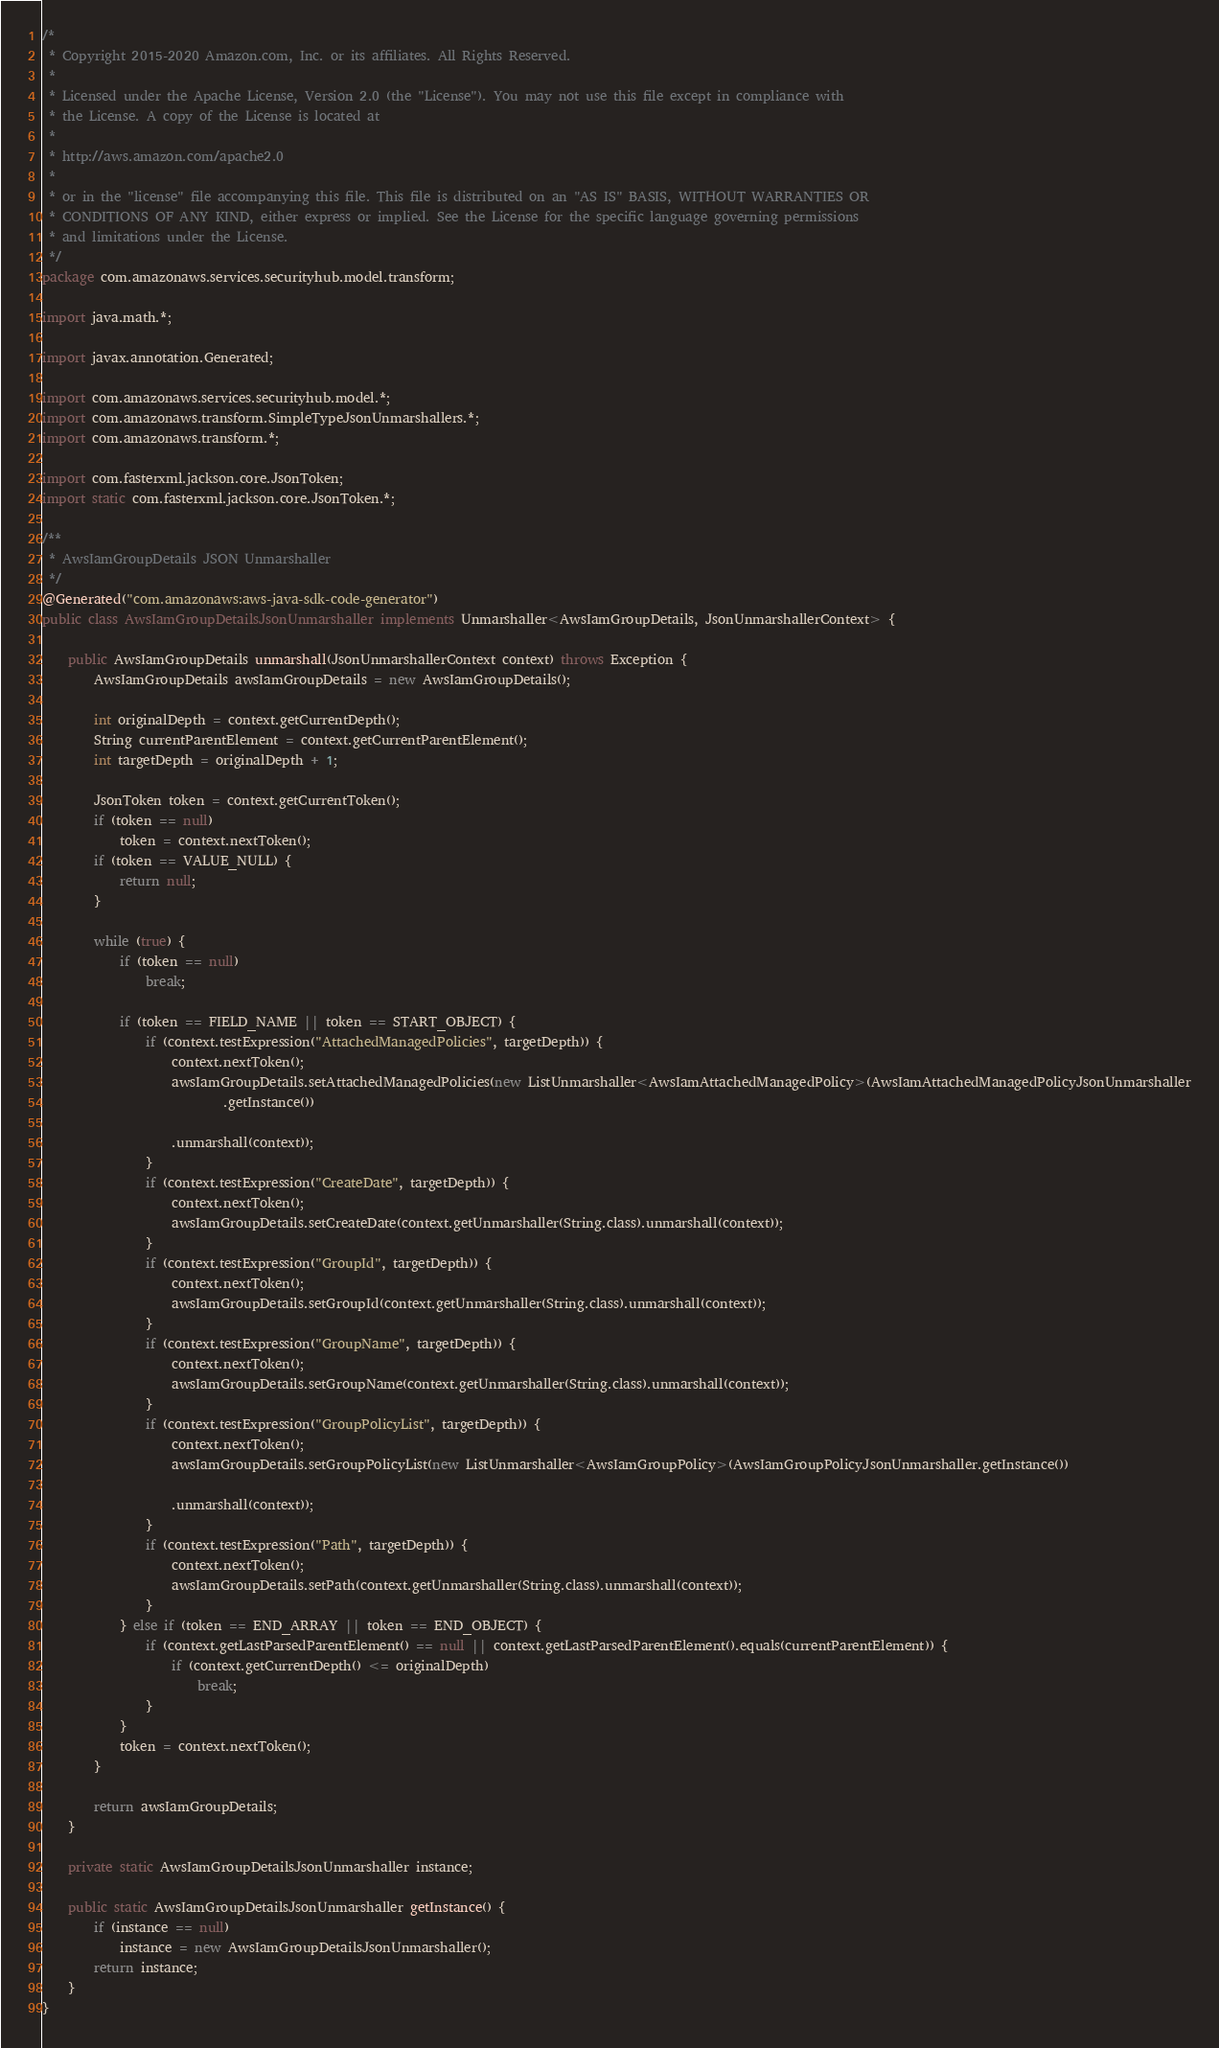Convert code to text. <code><loc_0><loc_0><loc_500><loc_500><_Java_>/*
 * Copyright 2015-2020 Amazon.com, Inc. or its affiliates. All Rights Reserved.
 * 
 * Licensed under the Apache License, Version 2.0 (the "License"). You may not use this file except in compliance with
 * the License. A copy of the License is located at
 * 
 * http://aws.amazon.com/apache2.0
 * 
 * or in the "license" file accompanying this file. This file is distributed on an "AS IS" BASIS, WITHOUT WARRANTIES OR
 * CONDITIONS OF ANY KIND, either express or implied. See the License for the specific language governing permissions
 * and limitations under the License.
 */
package com.amazonaws.services.securityhub.model.transform;

import java.math.*;

import javax.annotation.Generated;

import com.amazonaws.services.securityhub.model.*;
import com.amazonaws.transform.SimpleTypeJsonUnmarshallers.*;
import com.amazonaws.transform.*;

import com.fasterxml.jackson.core.JsonToken;
import static com.fasterxml.jackson.core.JsonToken.*;

/**
 * AwsIamGroupDetails JSON Unmarshaller
 */
@Generated("com.amazonaws:aws-java-sdk-code-generator")
public class AwsIamGroupDetailsJsonUnmarshaller implements Unmarshaller<AwsIamGroupDetails, JsonUnmarshallerContext> {

    public AwsIamGroupDetails unmarshall(JsonUnmarshallerContext context) throws Exception {
        AwsIamGroupDetails awsIamGroupDetails = new AwsIamGroupDetails();

        int originalDepth = context.getCurrentDepth();
        String currentParentElement = context.getCurrentParentElement();
        int targetDepth = originalDepth + 1;

        JsonToken token = context.getCurrentToken();
        if (token == null)
            token = context.nextToken();
        if (token == VALUE_NULL) {
            return null;
        }

        while (true) {
            if (token == null)
                break;

            if (token == FIELD_NAME || token == START_OBJECT) {
                if (context.testExpression("AttachedManagedPolicies", targetDepth)) {
                    context.nextToken();
                    awsIamGroupDetails.setAttachedManagedPolicies(new ListUnmarshaller<AwsIamAttachedManagedPolicy>(AwsIamAttachedManagedPolicyJsonUnmarshaller
                            .getInstance())

                    .unmarshall(context));
                }
                if (context.testExpression("CreateDate", targetDepth)) {
                    context.nextToken();
                    awsIamGroupDetails.setCreateDate(context.getUnmarshaller(String.class).unmarshall(context));
                }
                if (context.testExpression("GroupId", targetDepth)) {
                    context.nextToken();
                    awsIamGroupDetails.setGroupId(context.getUnmarshaller(String.class).unmarshall(context));
                }
                if (context.testExpression("GroupName", targetDepth)) {
                    context.nextToken();
                    awsIamGroupDetails.setGroupName(context.getUnmarshaller(String.class).unmarshall(context));
                }
                if (context.testExpression("GroupPolicyList", targetDepth)) {
                    context.nextToken();
                    awsIamGroupDetails.setGroupPolicyList(new ListUnmarshaller<AwsIamGroupPolicy>(AwsIamGroupPolicyJsonUnmarshaller.getInstance())

                    .unmarshall(context));
                }
                if (context.testExpression("Path", targetDepth)) {
                    context.nextToken();
                    awsIamGroupDetails.setPath(context.getUnmarshaller(String.class).unmarshall(context));
                }
            } else if (token == END_ARRAY || token == END_OBJECT) {
                if (context.getLastParsedParentElement() == null || context.getLastParsedParentElement().equals(currentParentElement)) {
                    if (context.getCurrentDepth() <= originalDepth)
                        break;
                }
            }
            token = context.nextToken();
        }

        return awsIamGroupDetails;
    }

    private static AwsIamGroupDetailsJsonUnmarshaller instance;

    public static AwsIamGroupDetailsJsonUnmarshaller getInstance() {
        if (instance == null)
            instance = new AwsIamGroupDetailsJsonUnmarshaller();
        return instance;
    }
}
</code> 